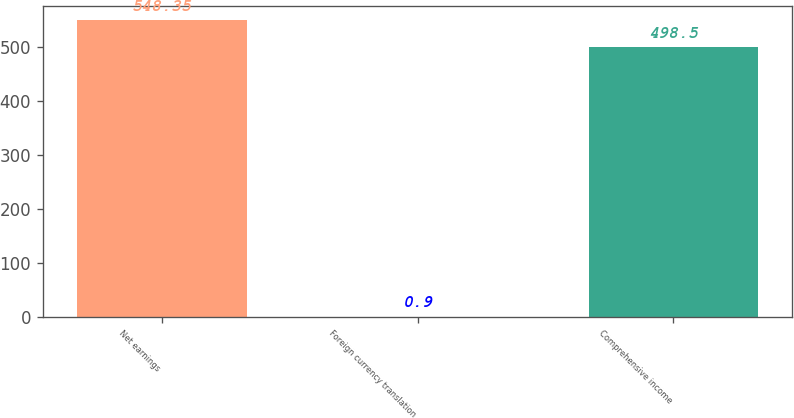Convert chart to OTSL. <chart><loc_0><loc_0><loc_500><loc_500><bar_chart><fcel>Net earnings<fcel>Foreign currency translation<fcel>Comprehensive income<nl><fcel>548.35<fcel>0.9<fcel>498.5<nl></chart> 